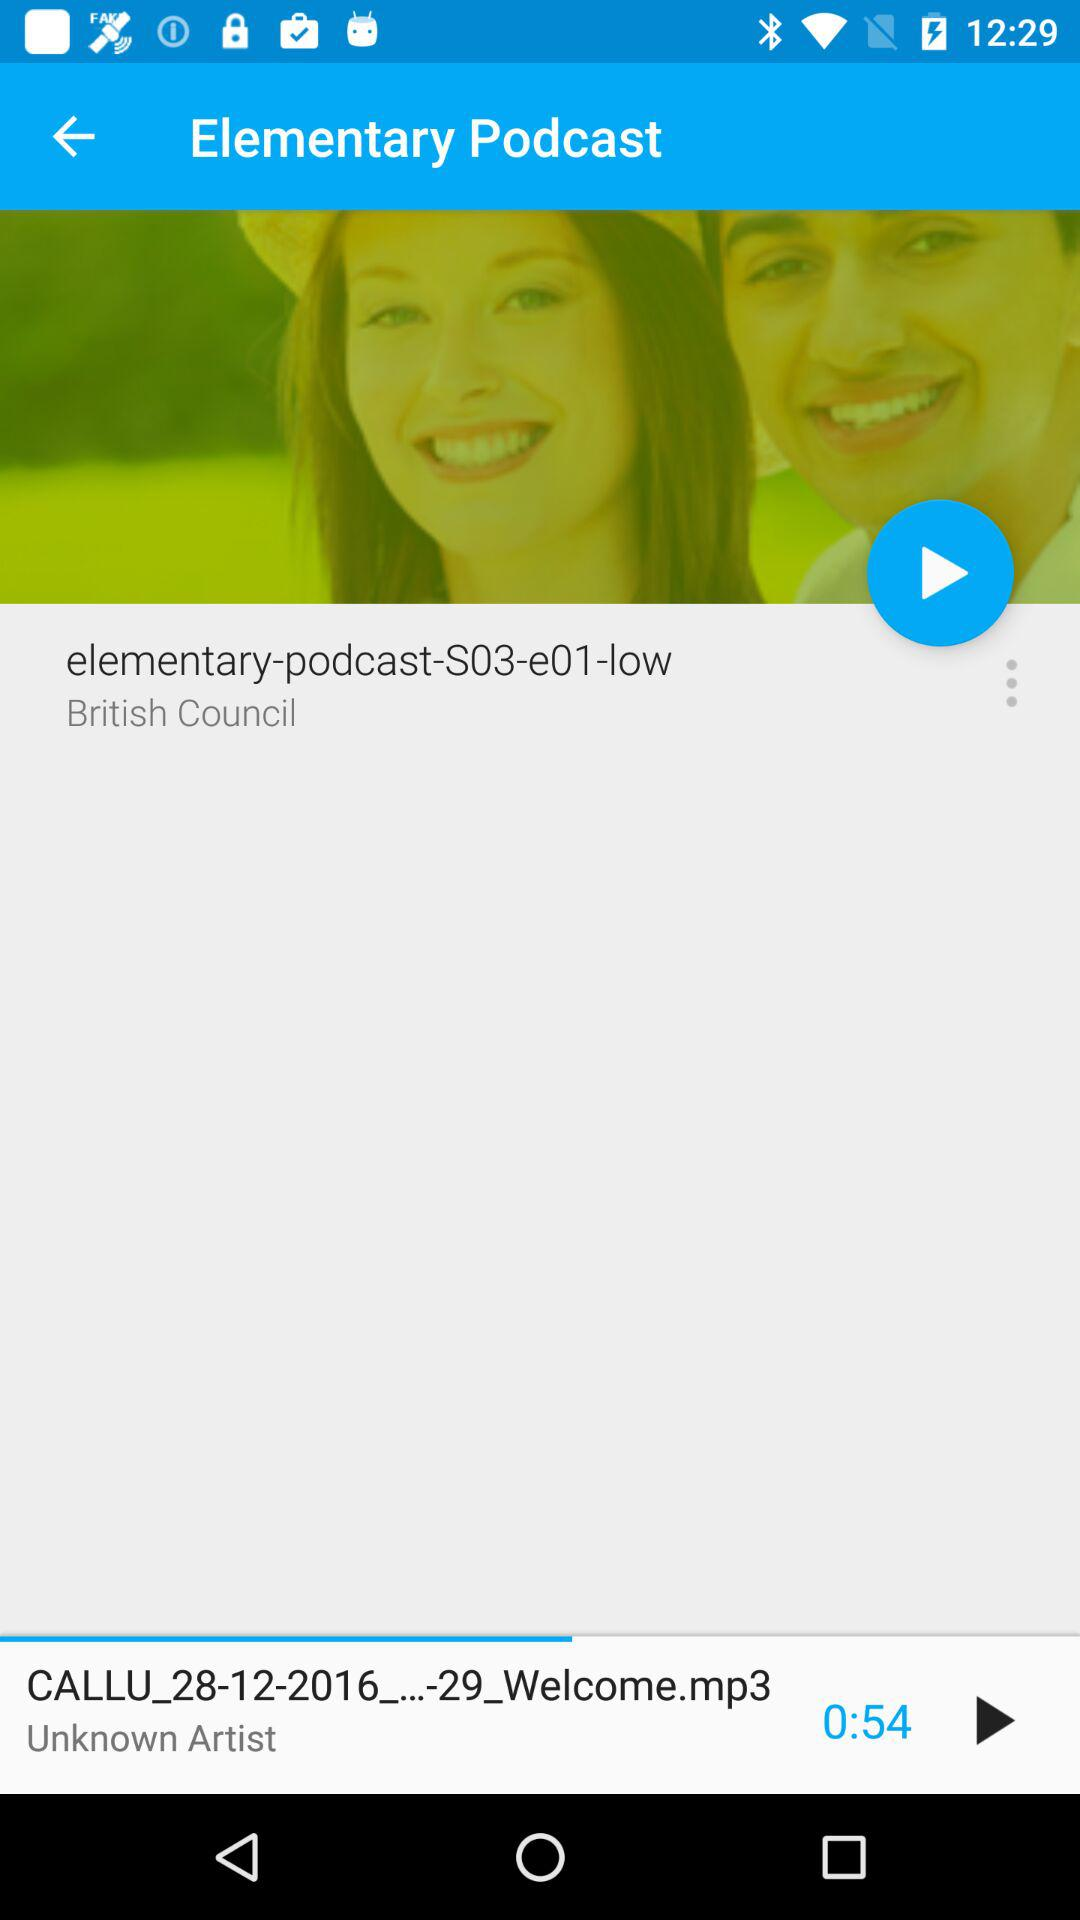What is the name of the artist?
Answer the question using a single word or phrase. Unknown Artist 